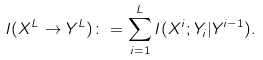Convert formula to latex. <formula><loc_0><loc_0><loc_500><loc_500>I ( { X } ^ { L } \to Y ^ { L } ) \colon = \sum _ { i = 1 } ^ { L } I ( { X } ^ { i } ; Y _ { i } | Y ^ { i - 1 } ) .</formula> 